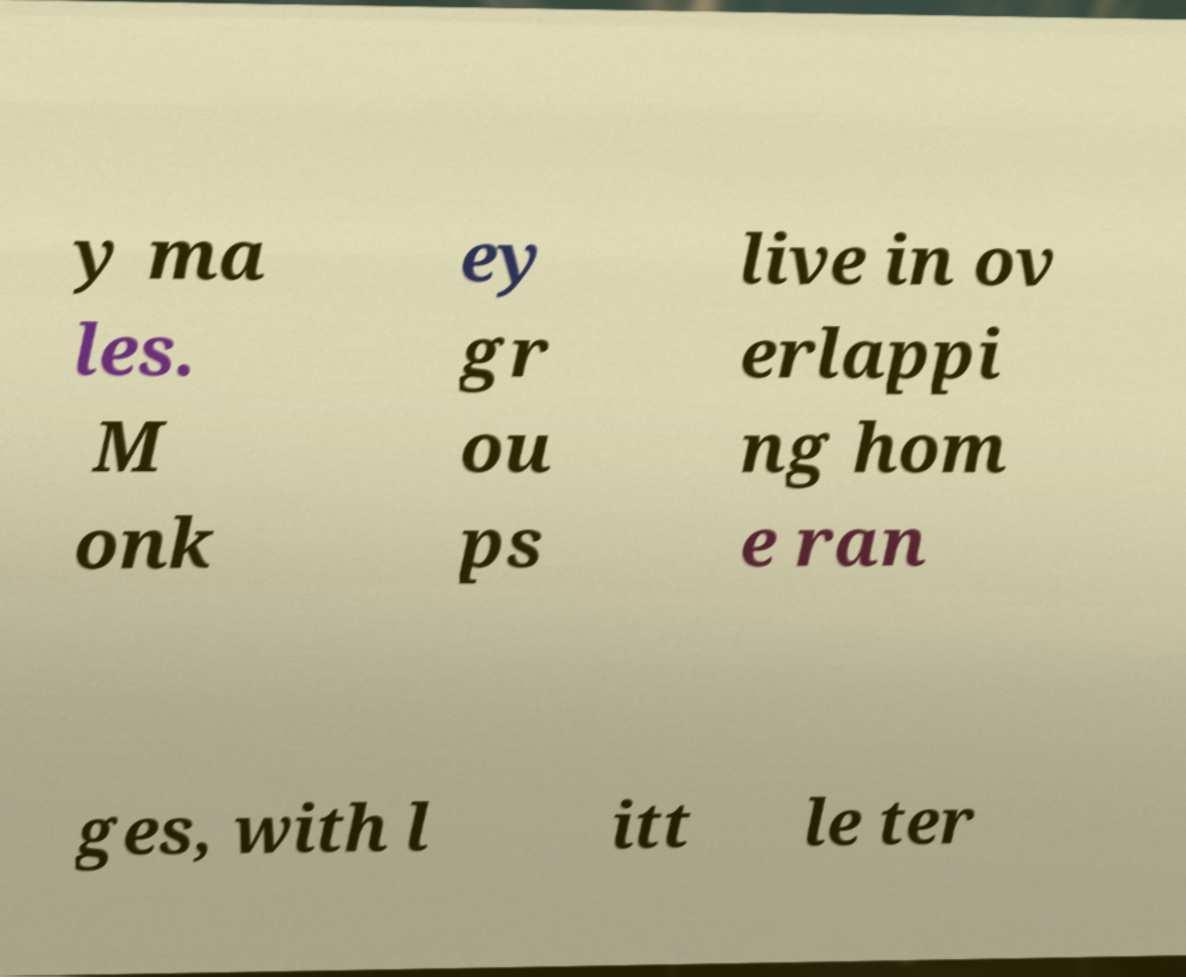What messages or text are displayed in this image? I need them in a readable, typed format. y ma les. M onk ey gr ou ps live in ov erlappi ng hom e ran ges, with l itt le ter 